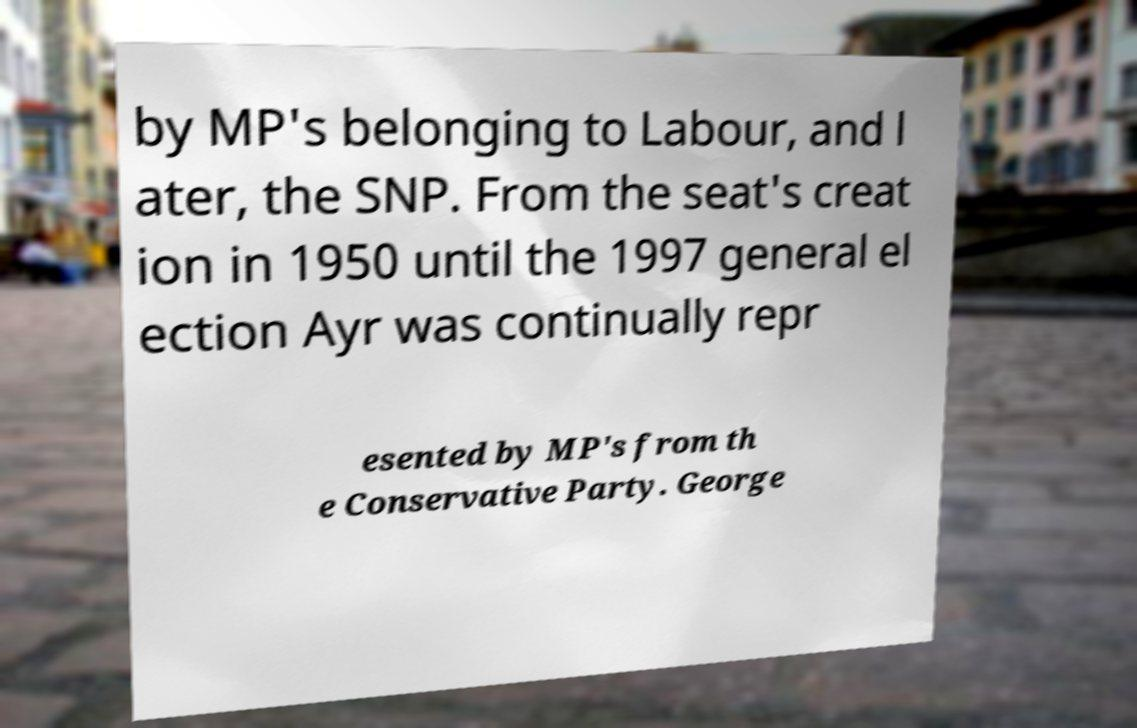Please read and relay the text visible in this image. What does it say? by MP's belonging to Labour, and l ater, the SNP. From the seat's creat ion in 1950 until the 1997 general el ection Ayr was continually repr esented by MP's from th e Conservative Party. George 